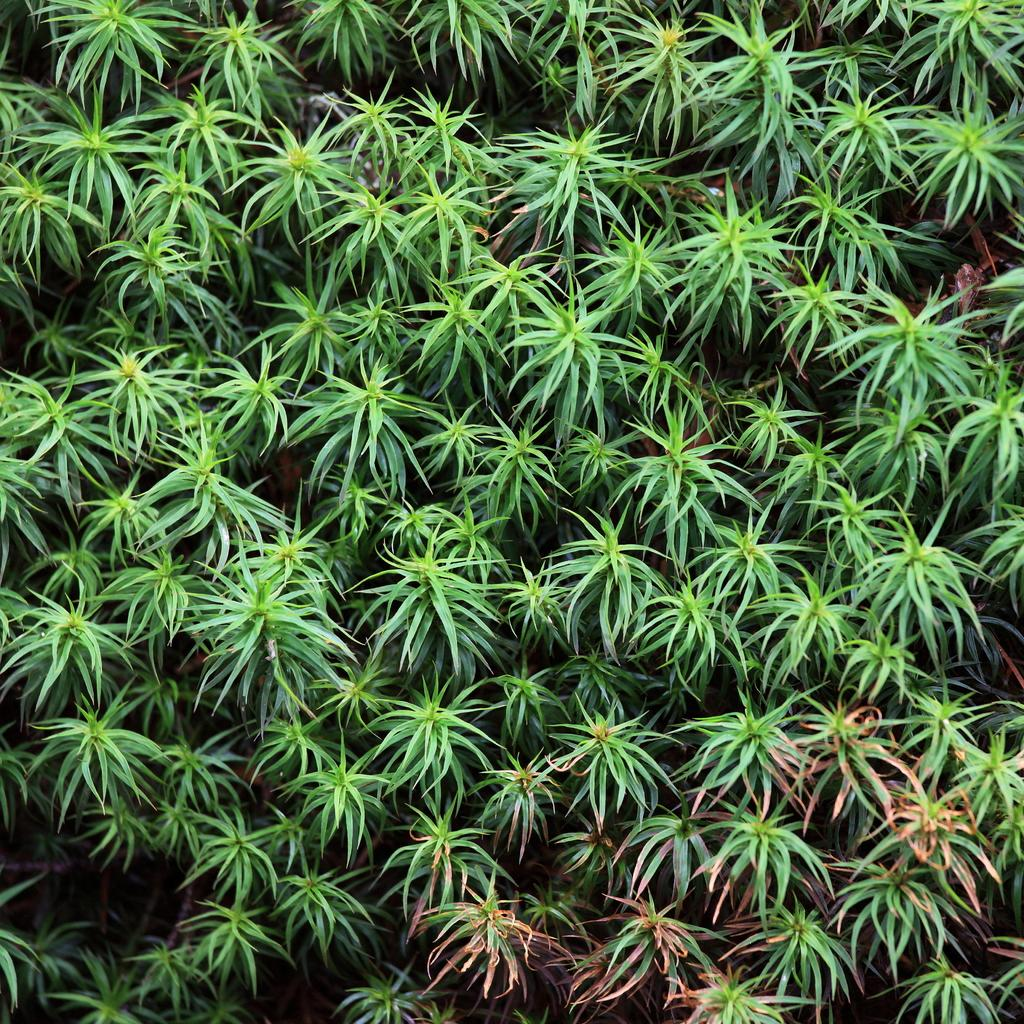What type of living organisms can be seen in the image? Plants can be seen in the image. What type of guide is helping the girl apply cream in the image? There is no guide, girl, or cream present in the image; it only features plants. 